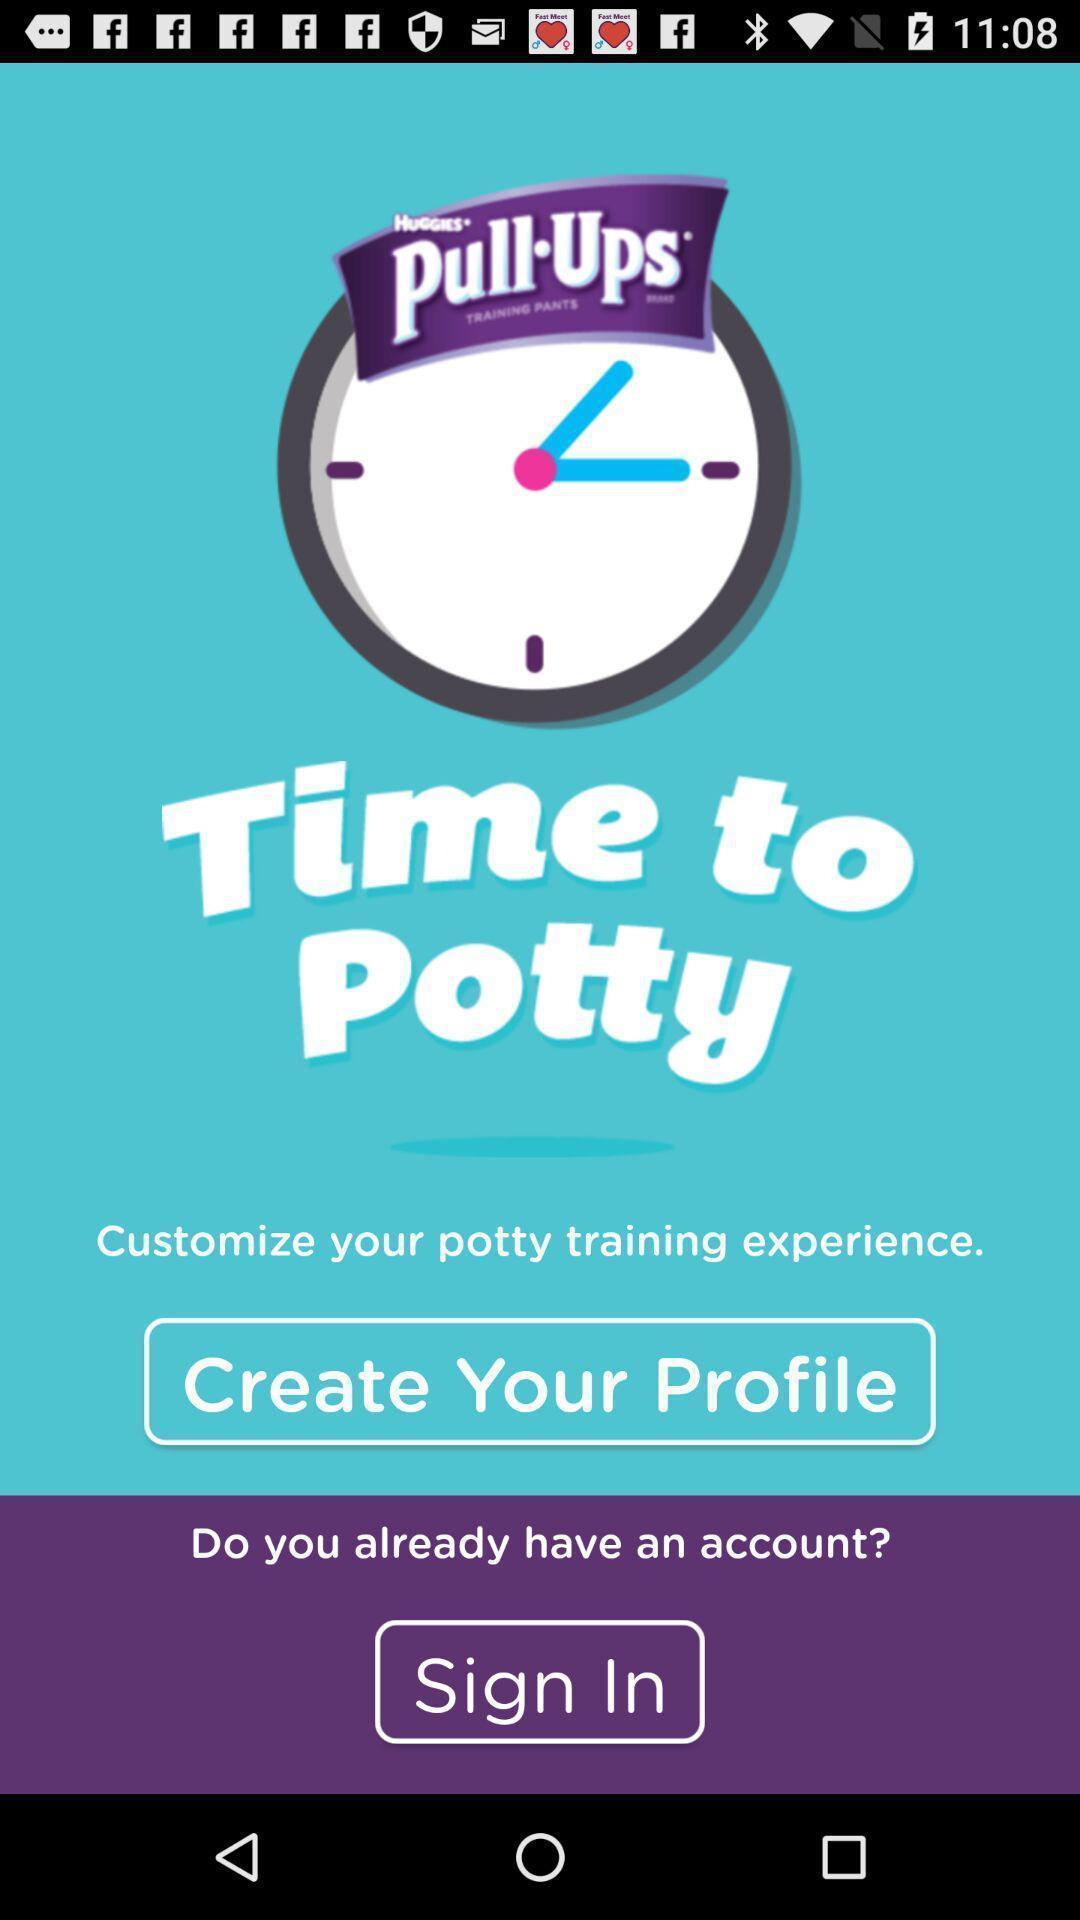What is the overall content of this screenshot? Welcome page of a fitness app. 